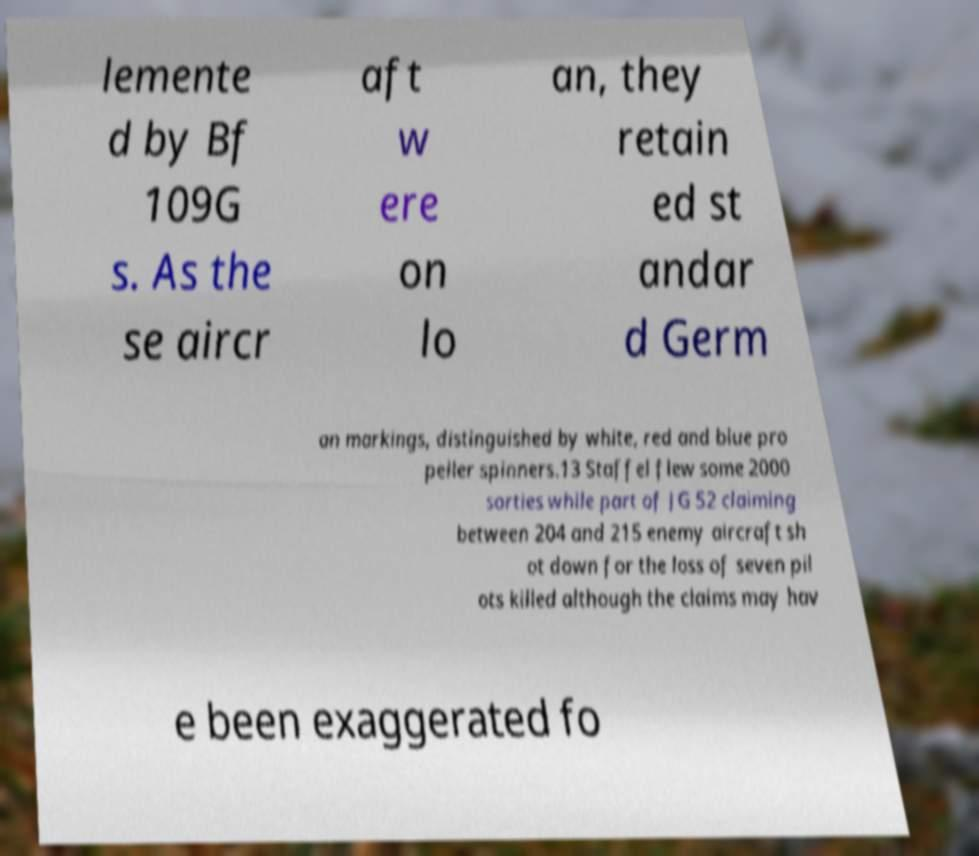What messages or text are displayed in this image? I need them in a readable, typed format. lemente d by Bf 109G s. As the se aircr aft w ere on lo an, they retain ed st andar d Germ an markings, distinguished by white, red and blue pro peller spinners.13 Staffel flew some 2000 sorties while part of JG 52 claiming between 204 and 215 enemy aircraft sh ot down for the loss of seven pil ots killed although the claims may hav e been exaggerated fo 